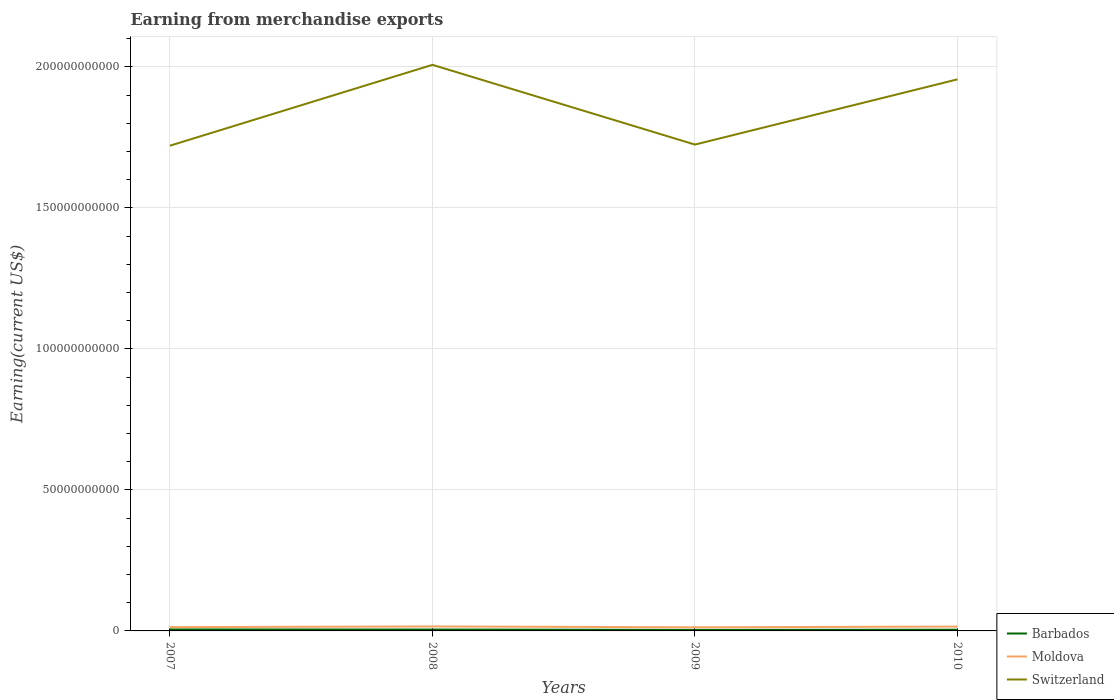How many different coloured lines are there?
Make the answer very short. 3. Does the line corresponding to Switzerland intersect with the line corresponding to Barbados?
Provide a short and direct response. No. Across all years, what is the maximum amount earned from merchandise exports in Switzerland?
Provide a short and direct response. 1.72e+11. In which year was the amount earned from merchandise exports in Moldova maximum?
Your answer should be very brief. 2009. What is the total amount earned from merchandise exports in Moldova in the graph?
Your answer should be very brief. -2.50e+08. What is the difference between the highest and the second highest amount earned from merchandise exports in Switzerland?
Ensure brevity in your answer.  2.87e+1. What is the difference between the highest and the lowest amount earned from merchandise exports in Switzerland?
Your answer should be very brief. 2. How many lines are there?
Offer a terse response. 3. How many years are there in the graph?
Your answer should be compact. 4. Where does the legend appear in the graph?
Your answer should be very brief. Bottom right. How many legend labels are there?
Give a very brief answer. 3. What is the title of the graph?
Your response must be concise. Earning from merchandise exports. Does "United States" appear as one of the legend labels in the graph?
Give a very brief answer. No. What is the label or title of the Y-axis?
Keep it short and to the point. Earning(current US$). What is the Earning(current US$) of Barbados in 2007?
Provide a succinct answer. 5.24e+08. What is the Earning(current US$) in Moldova in 2007?
Provide a succinct answer. 1.34e+09. What is the Earning(current US$) of Switzerland in 2007?
Offer a very short reply. 1.72e+11. What is the Earning(current US$) of Barbados in 2008?
Provide a short and direct response. 4.88e+08. What is the Earning(current US$) of Moldova in 2008?
Provide a succinct answer. 1.59e+09. What is the Earning(current US$) in Switzerland in 2008?
Give a very brief answer. 2.01e+11. What is the Earning(current US$) of Barbados in 2009?
Offer a terse response. 3.79e+08. What is the Earning(current US$) of Moldova in 2009?
Offer a terse response. 1.28e+09. What is the Earning(current US$) in Switzerland in 2009?
Your answer should be very brief. 1.72e+11. What is the Earning(current US$) of Barbados in 2010?
Provide a succinct answer. 4.29e+08. What is the Earning(current US$) in Moldova in 2010?
Your answer should be compact. 1.54e+09. What is the Earning(current US$) in Switzerland in 2010?
Give a very brief answer. 1.96e+11. Across all years, what is the maximum Earning(current US$) in Barbados?
Provide a short and direct response. 5.24e+08. Across all years, what is the maximum Earning(current US$) of Moldova?
Your response must be concise. 1.59e+09. Across all years, what is the maximum Earning(current US$) of Switzerland?
Give a very brief answer. 2.01e+11. Across all years, what is the minimum Earning(current US$) in Barbados?
Offer a very short reply. 3.79e+08. Across all years, what is the minimum Earning(current US$) of Moldova?
Offer a terse response. 1.28e+09. Across all years, what is the minimum Earning(current US$) in Switzerland?
Provide a short and direct response. 1.72e+11. What is the total Earning(current US$) in Barbados in the graph?
Provide a succinct answer. 1.82e+09. What is the total Earning(current US$) of Moldova in the graph?
Ensure brevity in your answer.  5.76e+09. What is the total Earning(current US$) in Switzerland in the graph?
Your response must be concise. 7.41e+11. What is the difference between the Earning(current US$) of Barbados in 2007 and that in 2008?
Offer a terse response. 3.60e+07. What is the difference between the Earning(current US$) of Moldova in 2007 and that in 2008?
Keep it short and to the point. -2.50e+08. What is the difference between the Earning(current US$) in Switzerland in 2007 and that in 2008?
Keep it short and to the point. -2.87e+1. What is the difference between the Earning(current US$) in Barbados in 2007 and that in 2009?
Provide a short and direct response. 1.45e+08. What is the difference between the Earning(current US$) of Moldova in 2007 and that in 2009?
Make the answer very short. 5.88e+07. What is the difference between the Earning(current US$) of Switzerland in 2007 and that in 2009?
Provide a short and direct response. -3.96e+08. What is the difference between the Earning(current US$) in Barbados in 2007 and that in 2010?
Offer a terse response. 9.48e+07. What is the difference between the Earning(current US$) of Moldova in 2007 and that in 2010?
Your answer should be very brief. -2.00e+08. What is the difference between the Earning(current US$) of Switzerland in 2007 and that in 2010?
Provide a succinct answer. -2.35e+1. What is the difference between the Earning(current US$) of Barbados in 2008 and that in 2009?
Offer a very short reply. 1.09e+08. What is the difference between the Earning(current US$) in Moldova in 2008 and that in 2009?
Make the answer very short. 3.08e+08. What is the difference between the Earning(current US$) of Switzerland in 2008 and that in 2009?
Offer a very short reply. 2.83e+1. What is the difference between the Earning(current US$) in Barbados in 2008 and that in 2010?
Your response must be concise. 5.88e+07. What is the difference between the Earning(current US$) in Moldova in 2008 and that in 2010?
Offer a terse response. 4.99e+07. What is the difference between the Earning(current US$) of Switzerland in 2008 and that in 2010?
Your answer should be very brief. 5.15e+09. What is the difference between the Earning(current US$) in Barbados in 2009 and that in 2010?
Provide a short and direct response. -5.05e+07. What is the difference between the Earning(current US$) of Moldova in 2009 and that in 2010?
Make the answer very short. -2.59e+08. What is the difference between the Earning(current US$) in Switzerland in 2009 and that in 2010?
Provide a succinct answer. -2.31e+1. What is the difference between the Earning(current US$) of Barbados in 2007 and the Earning(current US$) of Moldova in 2008?
Ensure brevity in your answer.  -1.07e+09. What is the difference between the Earning(current US$) of Barbados in 2007 and the Earning(current US$) of Switzerland in 2008?
Your answer should be compact. -2.00e+11. What is the difference between the Earning(current US$) of Moldova in 2007 and the Earning(current US$) of Switzerland in 2008?
Ensure brevity in your answer.  -1.99e+11. What is the difference between the Earning(current US$) in Barbados in 2007 and the Earning(current US$) in Moldova in 2009?
Make the answer very short. -7.59e+08. What is the difference between the Earning(current US$) in Barbados in 2007 and the Earning(current US$) in Switzerland in 2009?
Your answer should be very brief. -1.72e+11. What is the difference between the Earning(current US$) of Moldova in 2007 and the Earning(current US$) of Switzerland in 2009?
Offer a very short reply. -1.71e+11. What is the difference between the Earning(current US$) in Barbados in 2007 and the Earning(current US$) in Moldova in 2010?
Your response must be concise. -1.02e+09. What is the difference between the Earning(current US$) in Barbados in 2007 and the Earning(current US$) in Switzerland in 2010?
Make the answer very short. -1.95e+11. What is the difference between the Earning(current US$) of Moldova in 2007 and the Earning(current US$) of Switzerland in 2010?
Make the answer very short. -1.94e+11. What is the difference between the Earning(current US$) in Barbados in 2008 and the Earning(current US$) in Moldova in 2009?
Provide a succinct answer. -7.95e+08. What is the difference between the Earning(current US$) in Barbados in 2008 and the Earning(current US$) in Switzerland in 2009?
Give a very brief answer. -1.72e+11. What is the difference between the Earning(current US$) of Moldova in 2008 and the Earning(current US$) of Switzerland in 2009?
Provide a short and direct response. -1.71e+11. What is the difference between the Earning(current US$) in Barbados in 2008 and the Earning(current US$) in Moldova in 2010?
Your answer should be compact. -1.05e+09. What is the difference between the Earning(current US$) in Barbados in 2008 and the Earning(current US$) in Switzerland in 2010?
Make the answer very short. -1.95e+11. What is the difference between the Earning(current US$) of Moldova in 2008 and the Earning(current US$) of Switzerland in 2010?
Your response must be concise. -1.94e+11. What is the difference between the Earning(current US$) in Barbados in 2009 and the Earning(current US$) in Moldova in 2010?
Provide a short and direct response. -1.16e+09. What is the difference between the Earning(current US$) in Barbados in 2009 and the Earning(current US$) in Switzerland in 2010?
Keep it short and to the point. -1.95e+11. What is the difference between the Earning(current US$) in Moldova in 2009 and the Earning(current US$) in Switzerland in 2010?
Provide a succinct answer. -1.94e+11. What is the average Earning(current US$) in Barbados per year?
Provide a succinct answer. 4.55e+08. What is the average Earning(current US$) in Moldova per year?
Offer a terse response. 1.44e+09. What is the average Earning(current US$) in Switzerland per year?
Your answer should be very brief. 1.85e+11. In the year 2007, what is the difference between the Earning(current US$) in Barbados and Earning(current US$) in Moldova?
Ensure brevity in your answer.  -8.18e+08. In the year 2007, what is the difference between the Earning(current US$) in Barbados and Earning(current US$) in Switzerland?
Ensure brevity in your answer.  -1.72e+11. In the year 2007, what is the difference between the Earning(current US$) in Moldova and Earning(current US$) in Switzerland?
Your answer should be compact. -1.71e+11. In the year 2008, what is the difference between the Earning(current US$) in Barbados and Earning(current US$) in Moldova?
Offer a terse response. -1.10e+09. In the year 2008, what is the difference between the Earning(current US$) of Barbados and Earning(current US$) of Switzerland?
Give a very brief answer. -2.00e+11. In the year 2008, what is the difference between the Earning(current US$) in Moldova and Earning(current US$) in Switzerland?
Give a very brief answer. -1.99e+11. In the year 2009, what is the difference between the Earning(current US$) in Barbados and Earning(current US$) in Moldova?
Make the answer very short. -9.04e+08. In the year 2009, what is the difference between the Earning(current US$) in Barbados and Earning(current US$) in Switzerland?
Give a very brief answer. -1.72e+11. In the year 2009, what is the difference between the Earning(current US$) in Moldova and Earning(current US$) in Switzerland?
Your answer should be compact. -1.71e+11. In the year 2010, what is the difference between the Earning(current US$) of Barbados and Earning(current US$) of Moldova?
Your response must be concise. -1.11e+09. In the year 2010, what is the difference between the Earning(current US$) of Barbados and Earning(current US$) of Switzerland?
Provide a short and direct response. -1.95e+11. In the year 2010, what is the difference between the Earning(current US$) of Moldova and Earning(current US$) of Switzerland?
Keep it short and to the point. -1.94e+11. What is the ratio of the Earning(current US$) of Barbados in 2007 to that in 2008?
Your answer should be compact. 1.07. What is the ratio of the Earning(current US$) of Moldova in 2007 to that in 2008?
Your answer should be very brief. 0.84. What is the ratio of the Earning(current US$) in Barbados in 2007 to that in 2009?
Make the answer very short. 1.38. What is the ratio of the Earning(current US$) of Moldova in 2007 to that in 2009?
Provide a succinct answer. 1.05. What is the ratio of the Earning(current US$) of Barbados in 2007 to that in 2010?
Provide a short and direct response. 1.22. What is the ratio of the Earning(current US$) in Moldova in 2007 to that in 2010?
Your answer should be compact. 0.87. What is the ratio of the Earning(current US$) of Switzerland in 2007 to that in 2010?
Offer a terse response. 0.88. What is the ratio of the Earning(current US$) in Barbados in 2008 to that in 2009?
Offer a very short reply. 1.29. What is the ratio of the Earning(current US$) of Moldova in 2008 to that in 2009?
Your answer should be very brief. 1.24. What is the ratio of the Earning(current US$) in Switzerland in 2008 to that in 2009?
Ensure brevity in your answer.  1.16. What is the ratio of the Earning(current US$) of Barbados in 2008 to that in 2010?
Provide a succinct answer. 1.14. What is the ratio of the Earning(current US$) in Moldova in 2008 to that in 2010?
Give a very brief answer. 1.03. What is the ratio of the Earning(current US$) in Switzerland in 2008 to that in 2010?
Give a very brief answer. 1.03. What is the ratio of the Earning(current US$) of Barbados in 2009 to that in 2010?
Ensure brevity in your answer.  0.88. What is the ratio of the Earning(current US$) of Moldova in 2009 to that in 2010?
Your answer should be compact. 0.83. What is the ratio of the Earning(current US$) of Switzerland in 2009 to that in 2010?
Provide a succinct answer. 0.88. What is the difference between the highest and the second highest Earning(current US$) of Barbados?
Offer a very short reply. 3.60e+07. What is the difference between the highest and the second highest Earning(current US$) of Moldova?
Make the answer very short. 4.99e+07. What is the difference between the highest and the second highest Earning(current US$) of Switzerland?
Your answer should be compact. 5.15e+09. What is the difference between the highest and the lowest Earning(current US$) of Barbados?
Your response must be concise. 1.45e+08. What is the difference between the highest and the lowest Earning(current US$) in Moldova?
Your answer should be very brief. 3.08e+08. What is the difference between the highest and the lowest Earning(current US$) in Switzerland?
Offer a terse response. 2.87e+1. 